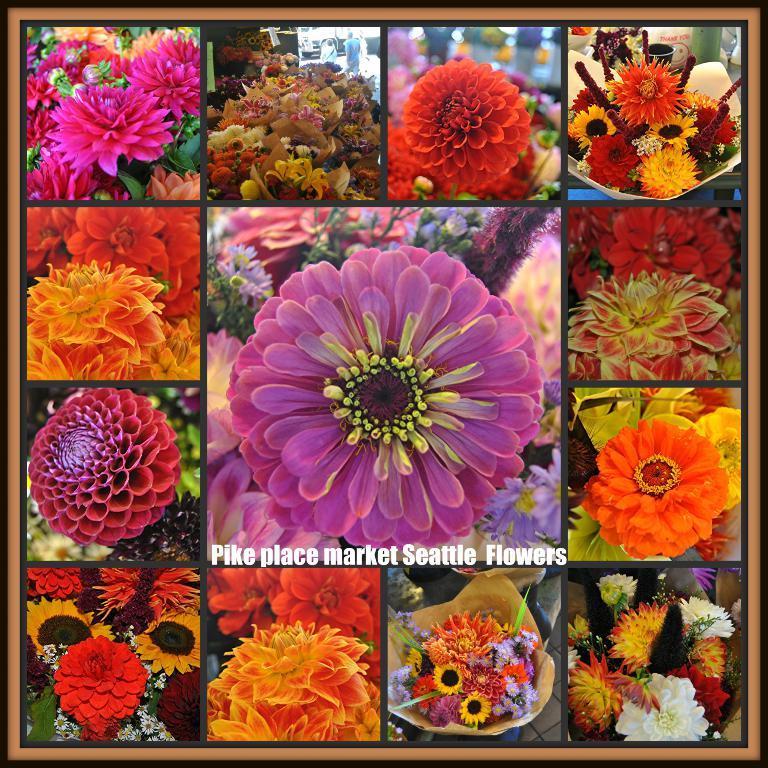Please provide a concise description of this image. In this image I can see many pictures edited and made as a collage image. Here I can see every picture consists of some different colorful flowers. At the bottom of the image there is some edited text. 